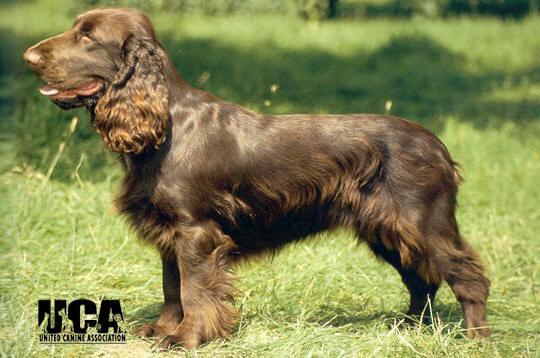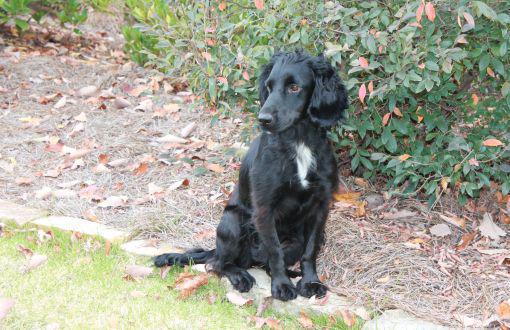The first image is the image on the left, the second image is the image on the right. For the images displayed, is the sentence "there are two dogs in the image pair" factually correct? Answer yes or no. Yes. The first image is the image on the left, the second image is the image on the right. Evaluate the accuracy of this statement regarding the images: "The combined images include a left-facing spaniel with something large held in its mouth, and a trio of three dogs sitting together in the grass.". Is it true? Answer yes or no. No. 